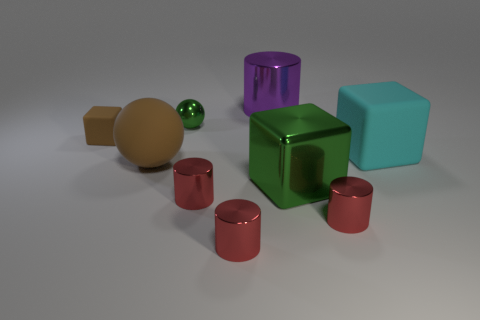What can you tell me about the colors of the objects in the image? The assortment of objects showcases a diverse palette of colors, ranging from muted earth tones to vibrant metallic shades. You can see bronzed gold, deep forest green, rich maroon and a bright reflective purple, with each color enhancing the visual interest of the scene and highlighting the shapes of the individual objects. 